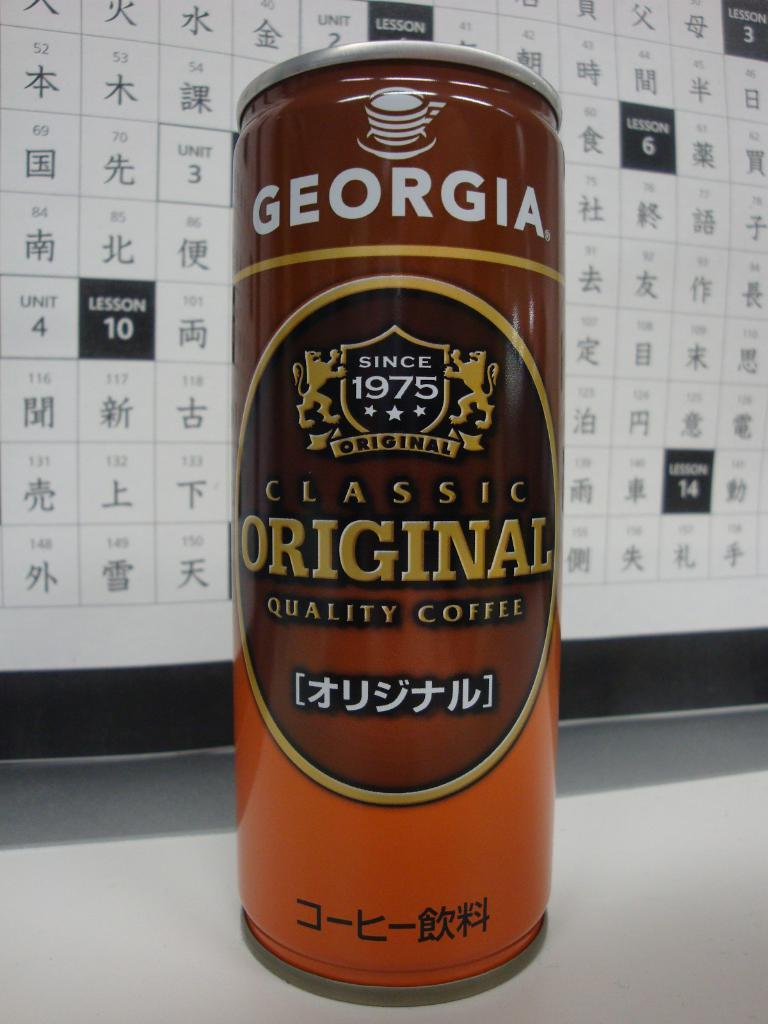Provide a one-sentence caption for the provided image. An orange and brown can of coffee is in front of a Chinese calendar and is the flavor Classic Original. 